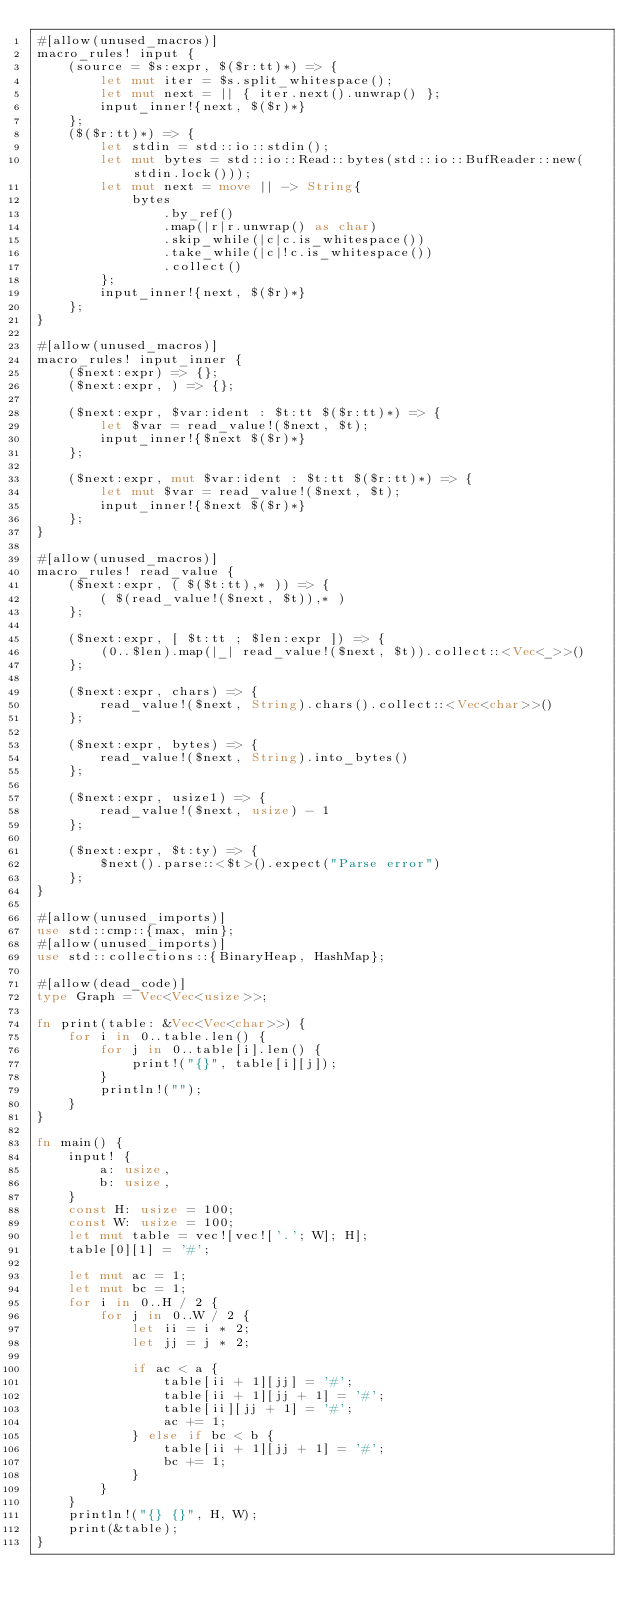<code> <loc_0><loc_0><loc_500><loc_500><_Rust_>#[allow(unused_macros)]
macro_rules! input {
    (source = $s:expr, $($r:tt)*) => {
        let mut iter = $s.split_whitespace();
        let mut next = || { iter.next().unwrap() };
        input_inner!{next, $($r)*}
    };
    ($($r:tt)*) => {
        let stdin = std::io::stdin();
        let mut bytes = std::io::Read::bytes(std::io::BufReader::new(stdin.lock()));
        let mut next = move || -> String{
            bytes
                .by_ref()
                .map(|r|r.unwrap() as char)
                .skip_while(|c|c.is_whitespace())
                .take_while(|c|!c.is_whitespace())
                .collect()
        };
        input_inner!{next, $($r)*}
    };
}

#[allow(unused_macros)]
macro_rules! input_inner {
    ($next:expr) => {};
    ($next:expr, ) => {};

    ($next:expr, $var:ident : $t:tt $($r:tt)*) => {
        let $var = read_value!($next, $t);
        input_inner!{$next $($r)*}
    };

    ($next:expr, mut $var:ident : $t:tt $($r:tt)*) => {
        let mut $var = read_value!($next, $t);
        input_inner!{$next $($r)*}
    };
}

#[allow(unused_macros)]
macro_rules! read_value {
    ($next:expr, ( $($t:tt),* )) => {
        ( $(read_value!($next, $t)),* )
    };

    ($next:expr, [ $t:tt ; $len:expr ]) => {
        (0..$len).map(|_| read_value!($next, $t)).collect::<Vec<_>>()
    };

    ($next:expr, chars) => {
        read_value!($next, String).chars().collect::<Vec<char>>()
    };

    ($next:expr, bytes) => {
        read_value!($next, String).into_bytes()
    };

    ($next:expr, usize1) => {
        read_value!($next, usize) - 1
    };

    ($next:expr, $t:ty) => {
        $next().parse::<$t>().expect("Parse error")
    };
}

#[allow(unused_imports)]
use std::cmp::{max, min};
#[allow(unused_imports)]
use std::collections::{BinaryHeap, HashMap};

#[allow(dead_code)]
type Graph = Vec<Vec<usize>>;

fn print(table: &Vec<Vec<char>>) {
    for i in 0..table.len() {
        for j in 0..table[i].len() {
            print!("{}", table[i][j]);
        }
        println!("");
    }
}

fn main() {
    input! {
        a: usize,
        b: usize,
    }
    const H: usize = 100;
    const W: usize = 100;
    let mut table = vec![vec!['.'; W]; H];
    table[0][1] = '#';

    let mut ac = 1;
    let mut bc = 1;
    for i in 0..H / 2 {
        for j in 0..W / 2 {
            let ii = i * 2;
            let jj = j * 2;

            if ac < a {
                table[ii + 1][jj] = '#';
                table[ii + 1][jj + 1] = '#';
                table[ii][jj + 1] = '#';
                ac += 1;
            } else if bc < b {
                table[ii + 1][jj + 1] = '#';
                bc += 1;
            }
        }
    }
    println!("{} {}", H, W);
    print(&table);
}
</code> 